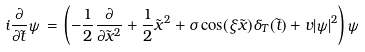<formula> <loc_0><loc_0><loc_500><loc_500>i \frac { \partial } { \partial \tilde { t } } \psi \, = \, \left ( - \frac { 1 } { 2 } \frac { \partial } { \partial \tilde { x } ^ { 2 } } + \frac { 1 } { 2 } \tilde { x } ^ { 2 } + \sigma \cos ( \xi \tilde { x } ) \delta _ { T } ( \tilde { t } ) + v | \psi | ^ { 2 } \right ) \psi</formula> 